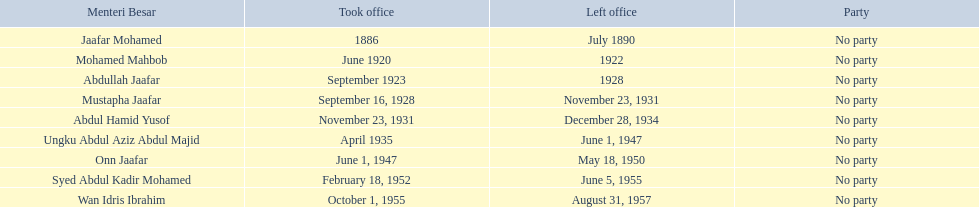Who were all of the menteri besars? Jaafar Mohamed, Mohamed Mahbob, Abdullah Jaafar, Mustapha Jaafar, Abdul Hamid Yusof, Ungku Abdul Aziz Abdul Majid, Onn Jaafar, Syed Abdul Kadir Mohamed, Wan Idris Ibrahim. When did they take office? 1886, June 1920, September 1923, September 16, 1928, November 23, 1931, April 1935, June 1, 1947, February 18, 1952, October 1, 1955. And when did they leave? July 1890, 1922, 1928, November 23, 1931, December 28, 1934, June 1, 1947, May 18, 1950, June 5, 1955, August 31, 1957. Now, who was in office for less than four years? Mohamed Mahbob. 